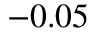Convert formula to latex. <formula><loc_0><loc_0><loc_500><loc_500>- 0 . 0 5</formula> 